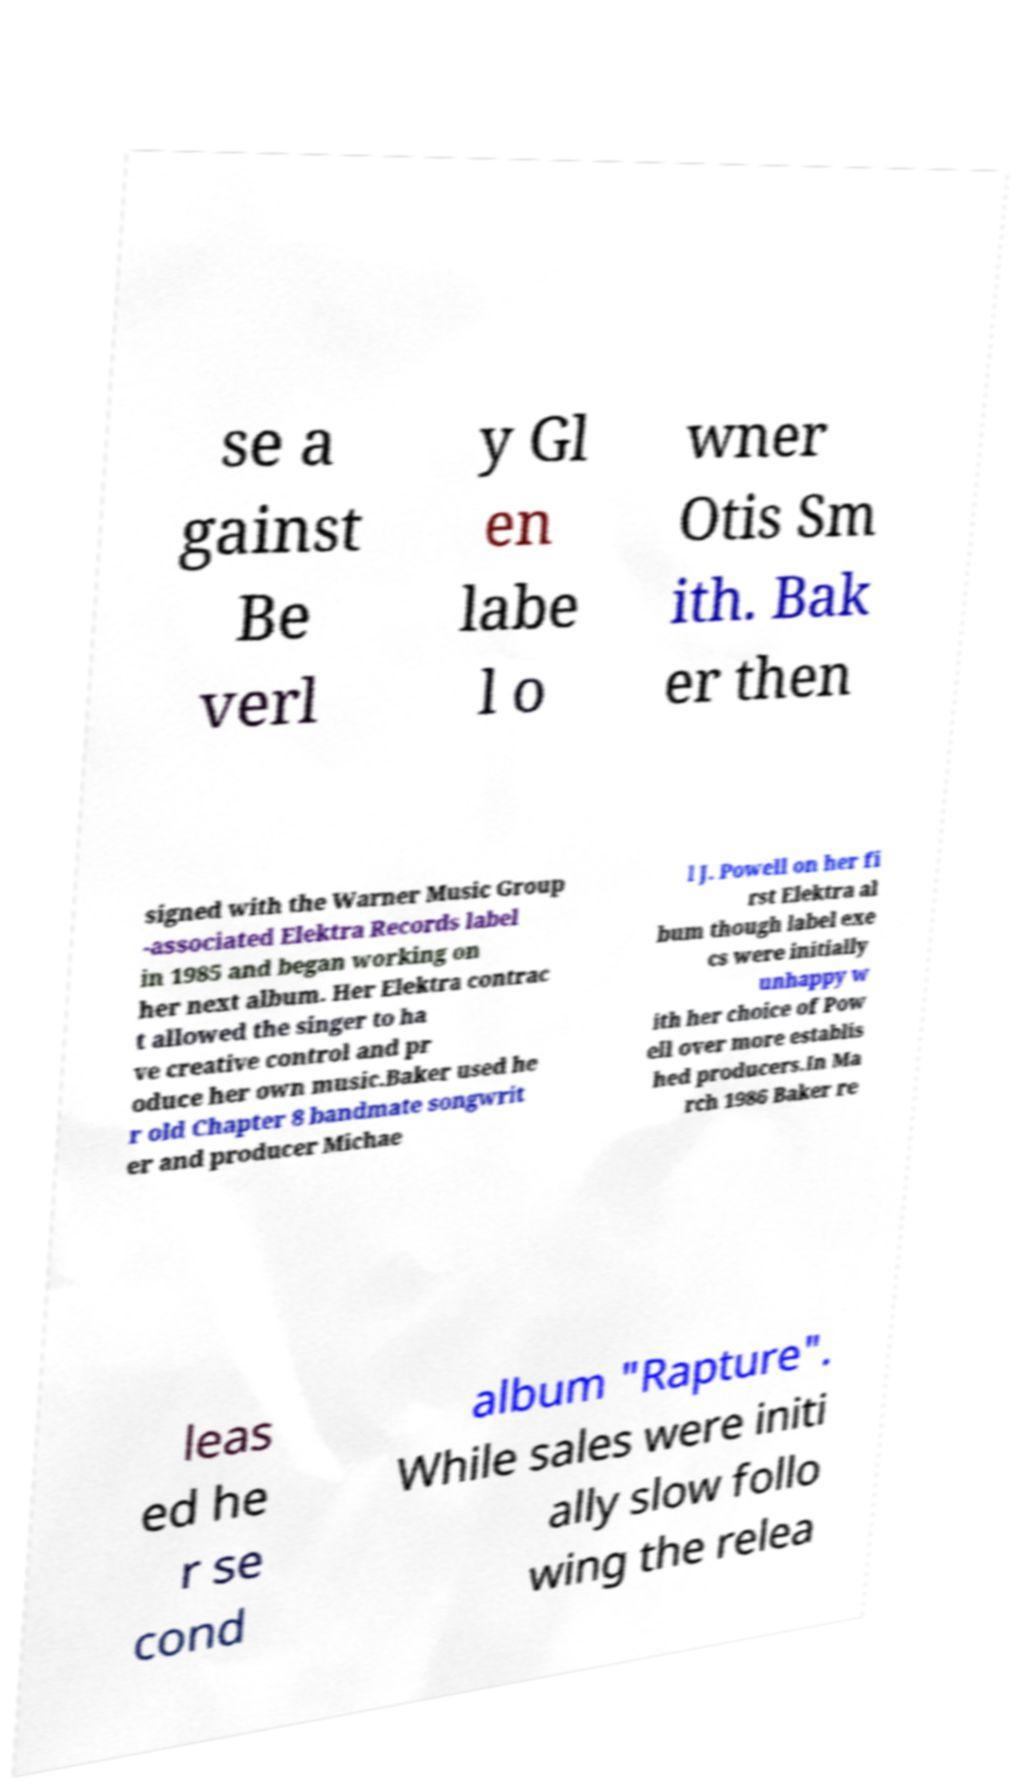Please read and relay the text visible in this image. What does it say? se a gainst Be verl y Gl en labe l o wner Otis Sm ith. Bak er then signed with the Warner Music Group -associated Elektra Records label in 1985 and began working on her next album. Her Elektra contrac t allowed the singer to ha ve creative control and pr oduce her own music.Baker used he r old Chapter 8 bandmate songwrit er and producer Michae l J. Powell on her fi rst Elektra al bum though label exe cs were initially unhappy w ith her choice of Pow ell over more establis hed producers.In Ma rch 1986 Baker re leas ed he r se cond album "Rapture". While sales were initi ally slow follo wing the relea 